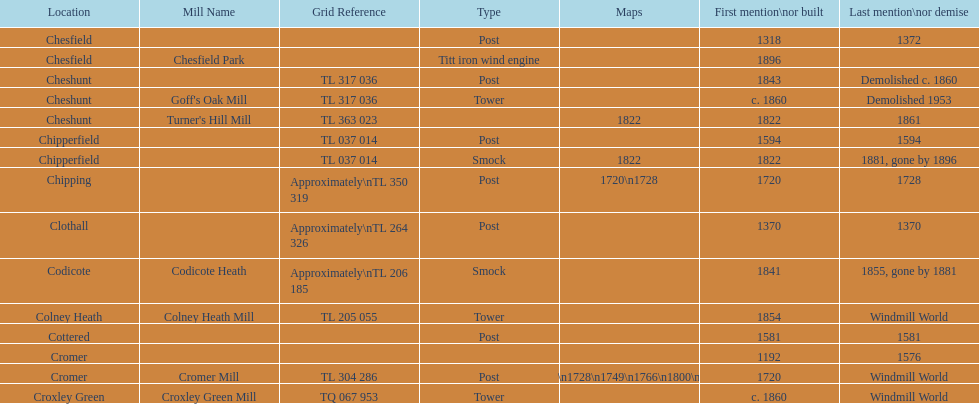How many mills were mentioned or built before 1700? 5. Parse the table in full. {'header': ['Location', 'Mill Name', 'Grid Reference', 'Type', 'Maps', 'First mention\\nor built', 'Last mention\\nor demise'], 'rows': [['Chesfield', '', '', 'Post', '', '1318', '1372'], ['Chesfield', 'Chesfield Park', '', 'Titt iron wind engine', '', '1896', ''], ['Cheshunt', '', 'TL 317 036', 'Post', '', '1843', 'Demolished c. 1860'], ['Cheshunt', "Goff's Oak Mill", 'TL 317 036', 'Tower', '', 'c. 1860', 'Demolished 1953'], ['Cheshunt', "Turner's Hill Mill", 'TL 363 023', '', '1822', '1822', '1861'], ['Chipperfield', '', 'TL 037 014', 'Post', '', '1594', '1594'], ['Chipperfield', '', 'TL 037 014', 'Smock', '1822', '1822', '1881, gone by 1896'], ['Chipping', '', 'Approximately\\nTL 350 319', 'Post', '1720\\n1728', '1720', '1728'], ['Clothall', '', 'Approximately\\nTL 264 326', 'Post', '', '1370', '1370'], ['Codicote', 'Codicote Heath', 'Approximately\\nTL 206 185', 'Smock', '', '1841', '1855, gone by 1881'], ['Colney Heath', 'Colney Heath Mill', 'TL 205 055', 'Tower', '', '1854', 'Windmill World'], ['Cottered', '', '', 'Post', '', '1581', '1581'], ['Cromer', '', '', '', '', '1192', '1576'], ['Cromer', 'Cromer Mill', 'TL 304 286', 'Post', '1720\\n1728\\n1749\\n1766\\n1800\\n1822', '1720', 'Windmill World'], ['Croxley Green', 'Croxley Green Mill', 'TQ 067 953', 'Tower', '', 'c. 1860', 'Windmill World']]} 